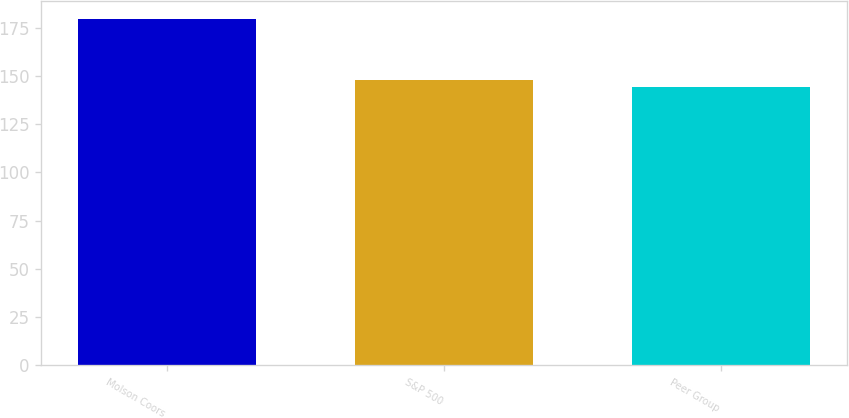Convert chart. <chart><loc_0><loc_0><loc_500><loc_500><bar_chart><fcel>Molson Coors<fcel>S&P 500<fcel>Peer Group<nl><fcel>179.63<fcel>147.83<fcel>144.3<nl></chart> 